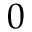Convert formula to latex. <formula><loc_0><loc_0><loc_500><loc_500>0</formula> 